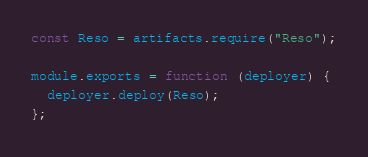<code> <loc_0><loc_0><loc_500><loc_500><_JavaScript_>const Reso = artifacts.require("Reso");

module.exports = function (deployer) {
  deployer.deploy(Reso);
};</code> 